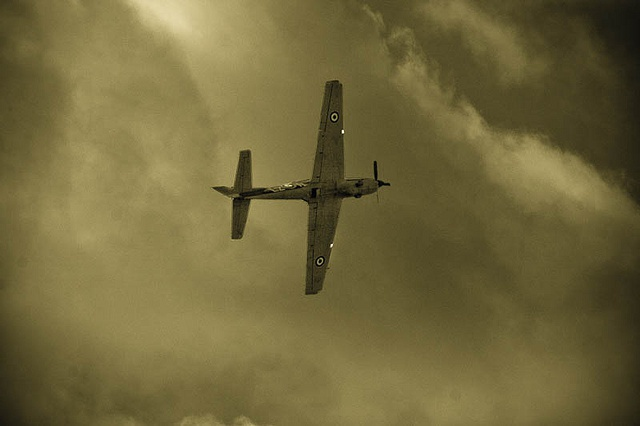Describe the objects in this image and their specific colors. I can see a airplane in black and olive tones in this image. 